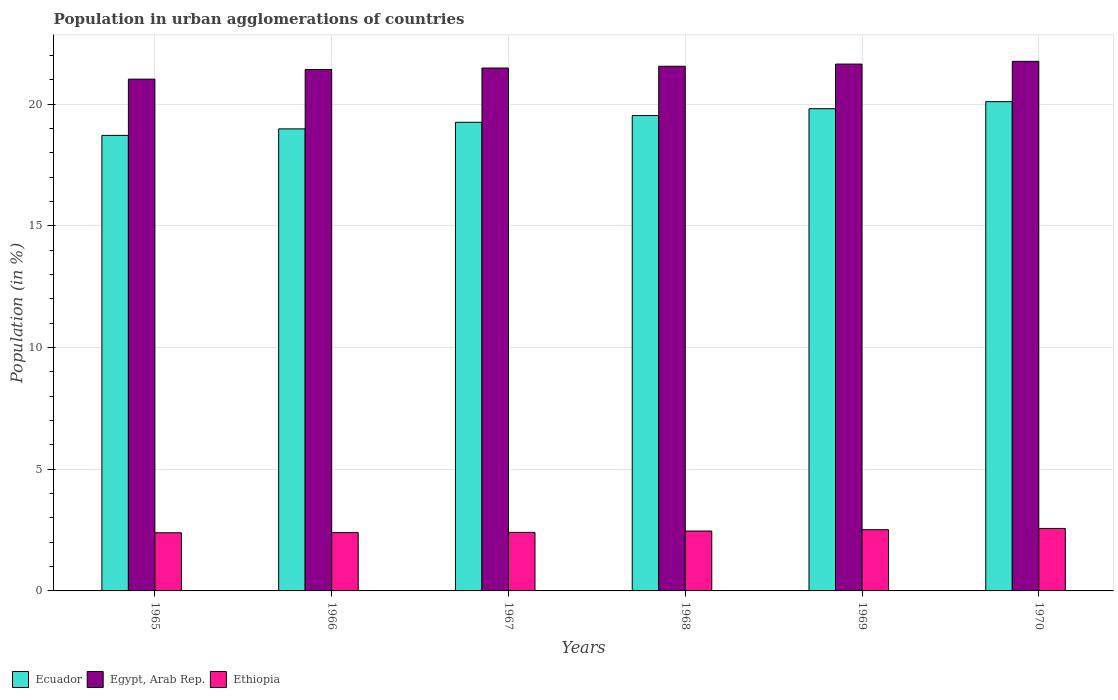How many different coloured bars are there?
Provide a succinct answer. 3. How many groups of bars are there?
Make the answer very short. 6. Are the number of bars per tick equal to the number of legend labels?
Give a very brief answer. Yes. Are the number of bars on each tick of the X-axis equal?
Your answer should be compact. Yes. What is the label of the 4th group of bars from the left?
Provide a short and direct response. 1968. What is the percentage of population in urban agglomerations in Egypt, Arab Rep. in 1968?
Keep it short and to the point. 21.55. Across all years, what is the maximum percentage of population in urban agglomerations in Ethiopia?
Your answer should be compact. 2.57. Across all years, what is the minimum percentage of population in urban agglomerations in Egypt, Arab Rep.?
Your response must be concise. 21.02. In which year was the percentage of population in urban agglomerations in Ecuador maximum?
Ensure brevity in your answer.  1970. In which year was the percentage of population in urban agglomerations in Ethiopia minimum?
Offer a very short reply. 1965. What is the total percentage of population in urban agglomerations in Ethiopia in the graph?
Your response must be concise. 14.73. What is the difference between the percentage of population in urban agglomerations in Ecuador in 1965 and that in 1969?
Provide a short and direct response. -1.1. What is the difference between the percentage of population in urban agglomerations in Ethiopia in 1965 and the percentage of population in urban agglomerations in Ecuador in 1966?
Ensure brevity in your answer.  -16.59. What is the average percentage of population in urban agglomerations in Egypt, Arab Rep. per year?
Offer a terse response. 21.48. In the year 1966, what is the difference between the percentage of population in urban agglomerations in Ethiopia and percentage of population in urban agglomerations in Ecuador?
Your answer should be compact. -16.58. In how many years, is the percentage of population in urban agglomerations in Ecuador greater than 5 %?
Provide a succinct answer. 6. What is the ratio of the percentage of population in urban agglomerations in Egypt, Arab Rep. in 1965 to that in 1968?
Your answer should be very brief. 0.98. Is the percentage of population in urban agglomerations in Ethiopia in 1966 less than that in 1968?
Your answer should be very brief. Yes. Is the difference between the percentage of population in urban agglomerations in Ethiopia in 1968 and 1970 greater than the difference between the percentage of population in urban agglomerations in Ecuador in 1968 and 1970?
Give a very brief answer. Yes. What is the difference between the highest and the second highest percentage of population in urban agglomerations in Egypt, Arab Rep.?
Offer a terse response. 0.11. What is the difference between the highest and the lowest percentage of population in urban agglomerations in Egypt, Arab Rep.?
Give a very brief answer. 0.73. Is the sum of the percentage of population in urban agglomerations in Egypt, Arab Rep. in 1966 and 1967 greater than the maximum percentage of population in urban agglomerations in Ethiopia across all years?
Offer a very short reply. Yes. What does the 2nd bar from the left in 1966 represents?
Offer a terse response. Egypt, Arab Rep. What does the 2nd bar from the right in 1967 represents?
Make the answer very short. Egypt, Arab Rep. How many bars are there?
Offer a very short reply. 18. Are all the bars in the graph horizontal?
Your answer should be very brief. No. Are the values on the major ticks of Y-axis written in scientific E-notation?
Provide a short and direct response. No. Does the graph contain grids?
Your answer should be very brief. Yes. How many legend labels are there?
Make the answer very short. 3. What is the title of the graph?
Keep it short and to the point. Population in urban agglomerations of countries. Does "Latin America(developing only)" appear as one of the legend labels in the graph?
Provide a short and direct response. No. What is the label or title of the X-axis?
Make the answer very short. Years. What is the label or title of the Y-axis?
Offer a very short reply. Population (in %). What is the Population (in %) in Ecuador in 1965?
Make the answer very short. 18.71. What is the Population (in %) of Egypt, Arab Rep. in 1965?
Keep it short and to the point. 21.02. What is the Population (in %) of Ethiopia in 1965?
Your answer should be very brief. 2.39. What is the Population (in %) in Ecuador in 1966?
Give a very brief answer. 18.98. What is the Population (in %) in Egypt, Arab Rep. in 1966?
Offer a very short reply. 21.42. What is the Population (in %) of Ethiopia in 1966?
Your answer should be compact. 2.4. What is the Population (in %) of Ecuador in 1967?
Provide a short and direct response. 19.25. What is the Population (in %) in Egypt, Arab Rep. in 1967?
Provide a succinct answer. 21.48. What is the Population (in %) of Ethiopia in 1967?
Your answer should be very brief. 2.4. What is the Population (in %) in Ecuador in 1968?
Your response must be concise. 19.53. What is the Population (in %) in Egypt, Arab Rep. in 1968?
Your answer should be compact. 21.55. What is the Population (in %) of Ethiopia in 1968?
Give a very brief answer. 2.46. What is the Population (in %) of Ecuador in 1969?
Offer a terse response. 19.81. What is the Population (in %) in Egypt, Arab Rep. in 1969?
Provide a succinct answer. 21.64. What is the Population (in %) of Ethiopia in 1969?
Offer a terse response. 2.51. What is the Population (in %) in Ecuador in 1970?
Ensure brevity in your answer.  20.1. What is the Population (in %) of Egypt, Arab Rep. in 1970?
Offer a very short reply. 21.75. What is the Population (in %) in Ethiopia in 1970?
Offer a terse response. 2.57. Across all years, what is the maximum Population (in %) of Ecuador?
Provide a succinct answer. 20.1. Across all years, what is the maximum Population (in %) of Egypt, Arab Rep.?
Offer a very short reply. 21.75. Across all years, what is the maximum Population (in %) of Ethiopia?
Your answer should be very brief. 2.57. Across all years, what is the minimum Population (in %) of Ecuador?
Ensure brevity in your answer.  18.71. Across all years, what is the minimum Population (in %) in Egypt, Arab Rep.?
Your answer should be compact. 21.02. Across all years, what is the minimum Population (in %) in Ethiopia?
Your answer should be very brief. 2.39. What is the total Population (in %) in Ecuador in the graph?
Your answer should be compact. 116.37. What is the total Population (in %) in Egypt, Arab Rep. in the graph?
Offer a very short reply. 128.86. What is the total Population (in %) in Ethiopia in the graph?
Provide a short and direct response. 14.73. What is the difference between the Population (in %) of Ecuador in 1965 and that in 1966?
Ensure brevity in your answer.  -0.27. What is the difference between the Population (in %) of Egypt, Arab Rep. in 1965 and that in 1966?
Offer a terse response. -0.4. What is the difference between the Population (in %) in Ethiopia in 1965 and that in 1966?
Provide a succinct answer. -0.01. What is the difference between the Population (in %) of Ecuador in 1965 and that in 1967?
Give a very brief answer. -0.54. What is the difference between the Population (in %) in Egypt, Arab Rep. in 1965 and that in 1967?
Provide a succinct answer. -0.46. What is the difference between the Population (in %) of Ethiopia in 1965 and that in 1967?
Give a very brief answer. -0.02. What is the difference between the Population (in %) of Ecuador in 1965 and that in 1968?
Provide a short and direct response. -0.81. What is the difference between the Population (in %) in Egypt, Arab Rep. in 1965 and that in 1968?
Your answer should be very brief. -0.53. What is the difference between the Population (in %) of Ethiopia in 1965 and that in 1968?
Offer a terse response. -0.07. What is the difference between the Population (in %) of Ecuador in 1965 and that in 1969?
Give a very brief answer. -1.1. What is the difference between the Population (in %) in Egypt, Arab Rep. in 1965 and that in 1969?
Your response must be concise. -0.62. What is the difference between the Population (in %) in Ethiopia in 1965 and that in 1969?
Your answer should be very brief. -0.13. What is the difference between the Population (in %) of Ecuador in 1965 and that in 1970?
Your answer should be very brief. -1.39. What is the difference between the Population (in %) in Egypt, Arab Rep. in 1965 and that in 1970?
Offer a very short reply. -0.73. What is the difference between the Population (in %) of Ethiopia in 1965 and that in 1970?
Offer a very short reply. -0.18. What is the difference between the Population (in %) in Ecuador in 1966 and that in 1967?
Provide a short and direct response. -0.27. What is the difference between the Population (in %) of Egypt, Arab Rep. in 1966 and that in 1967?
Ensure brevity in your answer.  -0.06. What is the difference between the Population (in %) of Ethiopia in 1966 and that in 1967?
Your answer should be very brief. -0.01. What is the difference between the Population (in %) in Ecuador in 1966 and that in 1968?
Your answer should be very brief. -0.55. What is the difference between the Population (in %) of Egypt, Arab Rep. in 1966 and that in 1968?
Provide a short and direct response. -0.13. What is the difference between the Population (in %) of Ethiopia in 1966 and that in 1968?
Offer a terse response. -0.06. What is the difference between the Population (in %) in Ecuador in 1966 and that in 1969?
Your answer should be compact. -0.83. What is the difference between the Population (in %) in Egypt, Arab Rep. in 1966 and that in 1969?
Give a very brief answer. -0.22. What is the difference between the Population (in %) of Ethiopia in 1966 and that in 1969?
Offer a terse response. -0.12. What is the difference between the Population (in %) in Ecuador in 1966 and that in 1970?
Ensure brevity in your answer.  -1.12. What is the difference between the Population (in %) of Egypt, Arab Rep. in 1966 and that in 1970?
Your response must be concise. -0.33. What is the difference between the Population (in %) of Ethiopia in 1966 and that in 1970?
Keep it short and to the point. -0.17. What is the difference between the Population (in %) in Ecuador in 1967 and that in 1968?
Provide a succinct answer. -0.28. What is the difference between the Population (in %) of Egypt, Arab Rep. in 1967 and that in 1968?
Offer a very short reply. -0.07. What is the difference between the Population (in %) in Ethiopia in 1967 and that in 1968?
Keep it short and to the point. -0.06. What is the difference between the Population (in %) of Ecuador in 1967 and that in 1969?
Keep it short and to the point. -0.56. What is the difference between the Population (in %) in Egypt, Arab Rep. in 1967 and that in 1969?
Your response must be concise. -0.16. What is the difference between the Population (in %) of Ethiopia in 1967 and that in 1969?
Keep it short and to the point. -0.11. What is the difference between the Population (in %) in Ecuador in 1967 and that in 1970?
Your response must be concise. -0.85. What is the difference between the Population (in %) of Egypt, Arab Rep. in 1967 and that in 1970?
Your answer should be compact. -0.27. What is the difference between the Population (in %) of Ethiopia in 1967 and that in 1970?
Your answer should be compact. -0.16. What is the difference between the Population (in %) of Ecuador in 1968 and that in 1969?
Keep it short and to the point. -0.28. What is the difference between the Population (in %) in Egypt, Arab Rep. in 1968 and that in 1969?
Offer a very short reply. -0.09. What is the difference between the Population (in %) of Ethiopia in 1968 and that in 1969?
Offer a very short reply. -0.05. What is the difference between the Population (in %) of Ecuador in 1968 and that in 1970?
Give a very brief answer. -0.57. What is the difference between the Population (in %) of Egypt, Arab Rep. in 1968 and that in 1970?
Your answer should be compact. -0.2. What is the difference between the Population (in %) of Ethiopia in 1968 and that in 1970?
Offer a very short reply. -0.11. What is the difference between the Population (in %) of Ecuador in 1969 and that in 1970?
Offer a terse response. -0.29. What is the difference between the Population (in %) in Egypt, Arab Rep. in 1969 and that in 1970?
Your answer should be very brief. -0.11. What is the difference between the Population (in %) of Ethiopia in 1969 and that in 1970?
Make the answer very short. -0.05. What is the difference between the Population (in %) of Ecuador in 1965 and the Population (in %) of Egypt, Arab Rep. in 1966?
Offer a terse response. -2.71. What is the difference between the Population (in %) in Ecuador in 1965 and the Population (in %) in Ethiopia in 1966?
Ensure brevity in your answer.  16.32. What is the difference between the Population (in %) of Egypt, Arab Rep. in 1965 and the Population (in %) of Ethiopia in 1966?
Offer a terse response. 18.63. What is the difference between the Population (in %) in Ecuador in 1965 and the Population (in %) in Egypt, Arab Rep. in 1967?
Provide a succinct answer. -2.77. What is the difference between the Population (in %) in Ecuador in 1965 and the Population (in %) in Ethiopia in 1967?
Keep it short and to the point. 16.31. What is the difference between the Population (in %) in Egypt, Arab Rep. in 1965 and the Population (in %) in Ethiopia in 1967?
Your answer should be compact. 18.62. What is the difference between the Population (in %) of Ecuador in 1965 and the Population (in %) of Egypt, Arab Rep. in 1968?
Ensure brevity in your answer.  -2.84. What is the difference between the Population (in %) of Ecuador in 1965 and the Population (in %) of Ethiopia in 1968?
Your answer should be very brief. 16.25. What is the difference between the Population (in %) in Egypt, Arab Rep. in 1965 and the Population (in %) in Ethiopia in 1968?
Offer a very short reply. 18.56. What is the difference between the Population (in %) in Ecuador in 1965 and the Population (in %) in Egypt, Arab Rep. in 1969?
Ensure brevity in your answer.  -2.93. What is the difference between the Population (in %) of Ecuador in 1965 and the Population (in %) of Ethiopia in 1969?
Your answer should be very brief. 16.2. What is the difference between the Population (in %) of Egypt, Arab Rep. in 1965 and the Population (in %) of Ethiopia in 1969?
Your response must be concise. 18.51. What is the difference between the Population (in %) in Ecuador in 1965 and the Population (in %) in Egypt, Arab Rep. in 1970?
Provide a succinct answer. -3.04. What is the difference between the Population (in %) in Ecuador in 1965 and the Population (in %) in Ethiopia in 1970?
Offer a terse response. 16.15. What is the difference between the Population (in %) in Egypt, Arab Rep. in 1965 and the Population (in %) in Ethiopia in 1970?
Make the answer very short. 18.46. What is the difference between the Population (in %) in Ecuador in 1966 and the Population (in %) in Egypt, Arab Rep. in 1967?
Give a very brief answer. -2.5. What is the difference between the Population (in %) in Ecuador in 1966 and the Population (in %) in Ethiopia in 1967?
Your answer should be compact. 16.57. What is the difference between the Population (in %) in Egypt, Arab Rep. in 1966 and the Population (in %) in Ethiopia in 1967?
Your response must be concise. 19.01. What is the difference between the Population (in %) of Ecuador in 1966 and the Population (in %) of Egypt, Arab Rep. in 1968?
Your response must be concise. -2.57. What is the difference between the Population (in %) in Ecuador in 1966 and the Population (in %) in Ethiopia in 1968?
Your answer should be compact. 16.52. What is the difference between the Population (in %) in Egypt, Arab Rep. in 1966 and the Population (in %) in Ethiopia in 1968?
Keep it short and to the point. 18.96. What is the difference between the Population (in %) of Ecuador in 1966 and the Population (in %) of Egypt, Arab Rep. in 1969?
Your answer should be compact. -2.66. What is the difference between the Population (in %) of Ecuador in 1966 and the Population (in %) of Ethiopia in 1969?
Keep it short and to the point. 16.46. What is the difference between the Population (in %) of Egypt, Arab Rep. in 1966 and the Population (in %) of Ethiopia in 1969?
Provide a succinct answer. 18.9. What is the difference between the Population (in %) in Ecuador in 1966 and the Population (in %) in Egypt, Arab Rep. in 1970?
Offer a terse response. -2.77. What is the difference between the Population (in %) in Ecuador in 1966 and the Population (in %) in Ethiopia in 1970?
Keep it short and to the point. 16.41. What is the difference between the Population (in %) in Egypt, Arab Rep. in 1966 and the Population (in %) in Ethiopia in 1970?
Ensure brevity in your answer.  18.85. What is the difference between the Population (in %) of Ecuador in 1967 and the Population (in %) of Egypt, Arab Rep. in 1968?
Your answer should be compact. -2.3. What is the difference between the Population (in %) of Ecuador in 1967 and the Population (in %) of Ethiopia in 1968?
Your answer should be very brief. 16.79. What is the difference between the Population (in %) of Egypt, Arab Rep. in 1967 and the Population (in %) of Ethiopia in 1968?
Make the answer very short. 19.02. What is the difference between the Population (in %) of Ecuador in 1967 and the Population (in %) of Egypt, Arab Rep. in 1969?
Make the answer very short. -2.39. What is the difference between the Population (in %) in Ecuador in 1967 and the Population (in %) in Ethiopia in 1969?
Keep it short and to the point. 16.74. What is the difference between the Population (in %) of Egypt, Arab Rep. in 1967 and the Population (in %) of Ethiopia in 1969?
Ensure brevity in your answer.  18.96. What is the difference between the Population (in %) in Ecuador in 1967 and the Population (in %) in Egypt, Arab Rep. in 1970?
Offer a very short reply. -2.5. What is the difference between the Population (in %) of Ecuador in 1967 and the Population (in %) of Ethiopia in 1970?
Keep it short and to the point. 16.68. What is the difference between the Population (in %) of Egypt, Arab Rep. in 1967 and the Population (in %) of Ethiopia in 1970?
Ensure brevity in your answer.  18.91. What is the difference between the Population (in %) of Ecuador in 1968 and the Population (in %) of Egypt, Arab Rep. in 1969?
Provide a succinct answer. -2.11. What is the difference between the Population (in %) of Ecuador in 1968 and the Population (in %) of Ethiopia in 1969?
Your answer should be compact. 17.01. What is the difference between the Population (in %) of Egypt, Arab Rep. in 1968 and the Population (in %) of Ethiopia in 1969?
Your answer should be very brief. 19.04. What is the difference between the Population (in %) in Ecuador in 1968 and the Population (in %) in Egypt, Arab Rep. in 1970?
Provide a short and direct response. -2.23. What is the difference between the Population (in %) of Ecuador in 1968 and the Population (in %) of Ethiopia in 1970?
Offer a very short reply. 16.96. What is the difference between the Population (in %) of Egypt, Arab Rep. in 1968 and the Population (in %) of Ethiopia in 1970?
Ensure brevity in your answer.  18.98. What is the difference between the Population (in %) in Ecuador in 1969 and the Population (in %) in Egypt, Arab Rep. in 1970?
Keep it short and to the point. -1.95. What is the difference between the Population (in %) of Ecuador in 1969 and the Population (in %) of Ethiopia in 1970?
Provide a short and direct response. 17.24. What is the difference between the Population (in %) of Egypt, Arab Rep. in 1969 and the Population (in %) of Ethiopia in 1970?
Keep it short and to the point. 19.07. What is the average Population (in %) of Ecuador per year?
Your answer should be compact. 19.39. What is the average Population (in %) in Egypt, Arab Rep. per year?
Offer a very short reply. 21.48. What is the average Population (in %) in Ethiopia per year?
Your answer should be very brief. 2.46. In the year 1965, what is the difference between the Population (in %) of Ecuador and Population (in %) of Egypt, Arab Rep.?
Your answer should be very brief. -2.31. In the year 1965, what is the difference between the Population (in %) in Ecuador and Population (in %) in Ethiopia?
Keep it short and to the point. 16.32. In the year 1965, what is the difference between the Population (in %) of Egypt, Arab Rep. and Population (in %) of Ethiopia?
Provide a short and direct response. 18.63. In the year 1966, what is the difference between the Population (in %) in Ecuador and Population (in %) in Egypt, Arab Rep.?
Your response must be concise. -2.44. In the year 1966, what is the difference between the Population (in %) of Ecuador and Population (in %) of Ethiopia?
Give a very brief answer. 16.58. In the year 1966, what is the difference between the Population (in %) in Egypt, Arab Rep. and Population (in %) in Ethiopia?
Provide a succinct answer. 19.02. In the year 1967, what is the difference between the Population (in %) in Ecuador and Population (in %) in Egypt, Arab Rep.?
Your answer should be very brief. -2.23. In the year 1967, what is the difference between the Population (in %) in Ecuador and Population (in %) in Ethiopia?
Provide a short and direct response. 16.84. In the year 1967, what is the difference between the Population (in %) of Egypt, Arab Rep. and Population (in %) of Ethiopia?
Provide a short and direct response. 19.07. In the year 1968, what is the difference between the Population (in %) in Ecuador and Population (in %) in Egypt, Arab Rep.?
Your response must be concise. -2.02. In the year 1968, what is the difference between the Population (in %) of Ecuador and Population (in %) of Ethiopia?
Provide a succinct answer. 17.07. In the year 1968, what is the difference between the Population (in %) in Egypt, Arab Rep. and Population (in %) in Ethiopia?
Your answer should be very brief. 19.09. In the year 1969, what is the difference between the Population (in %) of Ecuador and Population (in %) of Egypt, Arab Rep.?
Your answer should be very brief. -1.83. In the year 1969, what is the difference between the Population (in %) of Ecuador and Population (in %) of Ethiopia?
Ensure brevity in your answer.  17.29. In the year 1969, what is the difference between the Population (in %) in Egypt, Arab Rep. and Population (in %) in Ethiopia?
Your answer should be very brief. 19.13. In the year 1970, what is the difference between the Population (in %) in Ecuador and Population (in %) in Egypt, Arab Rep.?
Your answer should be compact. -1.66. In the year 1970, what is the difference between the Population (in %) in Ecuador and Population (in %) in Ethiopia?
Give a very brief answer. 17.53. In the year 1970, what is the difference between the Population (in %) in Egypt, Arab Rep. and Population (in %) in Ethiopia?
Provide a short and direct response. 19.19. What is the ratio of the Population (in %) in Ecuador in 1965 to that in 1966?
Make the answer very short. 0.99. What is the ratio of the Population (in %) in Egypt, Arab Rep. in 1965 to that in 1966?
Provide a succinct answer. 0.98. What is the ratio of the Population (in %) in Ecuador in 1965 to that in 1967?
Provide a short and direct response. 0.97. What is the ratio of the Population (in %) of Egypt, Arab Rep. in 1965 to that in 1967?
Give a very brief answer. 0.98. What is the ratio of the Population (in %) in Egypt, Arab Rep. in 1965 to that in 1968?
Offer a terse response. 0.98. What is the ratio of the Population (in %) in Ethiopia in 1965 to that in 1968?
Your response must be concise. 0.97. What is the ratio of the Population (in %) in Ecuador in 1965 to that in 1969?
Keep it short and to the point. 0.94. What is the ratio of the Population (in %) of Egypt, Arab Rep. in 1965 to that in 1969?
Your answer should be compact. 0.97. What is the ratio of the Population (in %) of Ethiopia in 1965 to that in 1969?
Keep it short and to the point. 0.95. What is the ratio of the Population (in %) in Ecuador in 1965 to that in 1970?
Keep it short and to the point. 0.93. What is the ratio of the Population (in %) of Egypt, Arab Rep. in 1965 to that in 1970?
Ensure brevity in your answer.  0.97. What is the ratio of the Population (in %) of Ethiopia in 1965 to that in 1970?
Your answer should be very brief. 0.93. What is the ratio of the Population (in %) in Ecuador in 1966 to that in 1967?
Keep it short and to the point. 0.99. What is the ratio of the Population (in %) in Egypt, Arab Rep. in 1966 to that in 1967?
Give a very brief answer. 1. What is the ratio of the Population (in %) in Ethiopia in 1966 to that in 1967?
Your answer should be very brief. 1. What is the ratio of the Population (in %) in Ethiopia in 1966 to that in 1968?
Provide a short and direct response. 0.97. What is the ratio of the Population (in %) of Ecuador in 1966 to that in 1969?
Offer a very short reply. 0.96. What is the ratio of the Population (in %) in Egypt, Arab Rep. in 1966 to that in 1969?
Your answer should be compact. 0.99. What is the ratio of the Population (in %) in Ethiopia in 1966 to that in 1969?
Ensure brevity in your answer.  0.95. What is the ratio of the Population (in %) in Egypt, Arab Rep. in 1966 to that in 1970?
Provide a succinct answer. 0.98. What is the ratio of the Population (in %) in Ethiopia in 1966 to that in 1970?
Keep it short and to the point. 0.93. What is the ratio of the Population (in %) in Ecuador in 1967 to that in 1968?
Your answer should be compact. 0.99. What is the ratio of the Population (in %) in Ethiopia in 1967 to that in 1968?
Give a very brief answer. 0.98. What is the ratio of the Population (in %) of Ecuador in 1967 to that in 1969?
Your response must be concise. 0.97. What is the ratio of the Population (in %) in Ethiopia in 1967 to that in 1969?
Keep it short and to the point. 0.96. What is the ratio of the Population (in %) in Ecuador in 1967 to that in 1970?
Give a very brief answer. 0.96. What is the ratio of the Population (in %) of Egypt, Arab Rep. in 1967 to that in 1970?
Your answer should be very brief. 0.99. What is the ratio of the Population (in %) in Ethiopia in 1967 to that in 1970?
Keep it short and to the point. 0.94. What is the ratio of the Population (in %) in Ecuador in 1968 to that in 1969?
Offer a very short reply. 0.99. What is the ratio of the Population (in %) of Egypt, Arab Rep. in 1968 to that in 1969?
Provide a succinct answer. 1. What is the ratio of the Population (in %) of Ethiopia in 1968 to that in 1969?
Make the answer very short. 0.98. What is the ratio of the Population (in %) of Ecuador in 1968 to that in 1970?
Offer a very short reply. 0.97. What is the ratio of the Population (in %) of Egypt, Arab Rep. in 1968 to that in 1970?
Provide a short and direct response. 0.99. What is the ratio of the Population (in %) of Ethiopia in 1968 to that in 1970?
Offer a terse response. 0.96. What is the ratio of the Population (in %) in Ecuador in 1969 to that in 1970?
Offer a very short reply. 0.99. What is the ratio of the Population (in %) of Egypt, Arab Rep. in 1969 to that in 1970?
Give a very brief answer. 0.99. What is the ratio of the Population (in %) of Ethiopia in 1969 to that in 1970?
Keep it short and to the point. 0.98. What is the difference between the highest and the second highest Population (in %) in Ecuador?
Give a very brief answer. 0.29. What is the difference between the highest and the second highest Population (in %) in Egypt, Arab Rep.?
Your response must be concise. 0.11. What is the difference between the highest and the second highest Population (in %) of Ethiopia?
Your answer should be very brief. 0.05. What is the difference between the highest and the lowest Population (in %) of Ecuador?
Your answer should be very brief. 1.39. What is the difference between the highest and the lowest Population (in %) in Egypt, Arab Rep.?
Offer a terse response. 0.73. What is the difference between the highest and the lowest Population (in %) of Ethiopia?
Offer a very short reply. 0.18. 